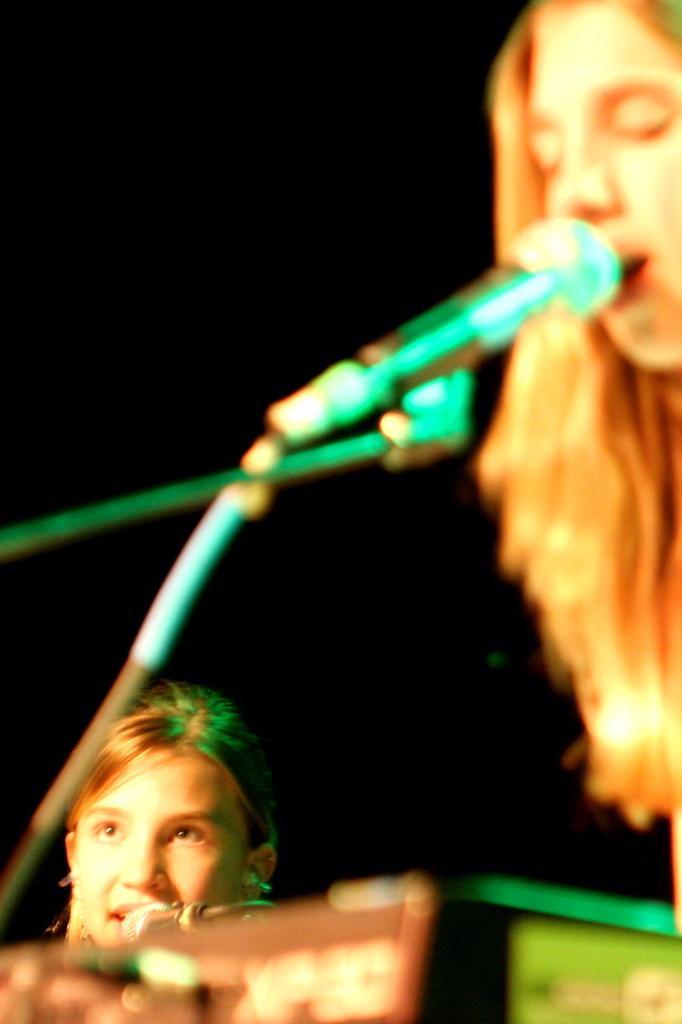Could you give a brief overview of what you see in this image? In this image we can see two persons and in front of them there is a mic and it looks like there are singing. The background image is dark. 